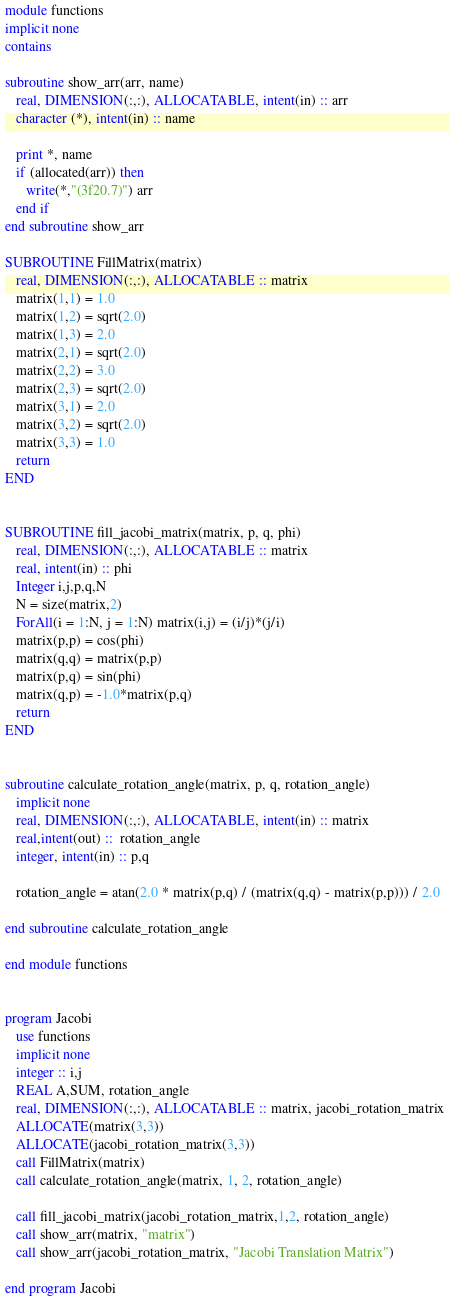<code> <loc_0><loc_0><loc_500><loc_500><_FORTRAN_>module functions
implicit none
contains

subroutine show_arr(arr, name)
   real, DIMENSION(:,:), ALLOCATABLE, intent(in) :: arr
   character (*), intent(in) :: name

   print *, name
   if (allocated(arr)) then
      write(*,"(3f20.7)") arr
   end if
end subroutine show_arr

SUBROUTINE FillMatrix(matrix)
   real, DIMENSION(:,:), ALLOCATABLE :: matrix
   matrix(1,1) = 1.0
   matrix(1,2) = sqrt(2.0)
   matrix(1,3) = 2.0
   matrix(2,1) = sqrt(2.0)
   matrix(2,2) = 3.0
   matrix(2,3) = sqrt(2.0)
   matrix(3,1) = 2.0
   matrix(3,2) = sqrt(2.0)
   matrix(3,3) = 1.0
   return
END


SUBROUTINE fill_jacobi_matrix(matrix, p, q, phi)
   real, DIMENSION(:,:), ALLOCATABLE :: matrix
   real, intent(in) :: phi
   Integer i,j,p,q,N
   N = size(matrix,2)
   ForAll(i = 1:N, j = 1:N) matrix(i,j) = (i/j)*(j/i)
   matrix(p,p) = cos(phi)
   matrix(q,q) = matrix(p,p)
   matrix(p,q) = sin(phi)
   matrix(q,p) = -1.0*matrix(p,q)
   return
END


subroutine calculate_rotation_angle(matrix, p, q, rotation_angle)
   implicit none
   real, DIMENSION(:,:), ALLOCATABLE, intent(in) :: matrix
   real,intent(out) ::  rotation_angle
   integer, intent(in) :: p,q

   rotation_angle = atan(2.0 * matrix(p,q) / (matrix(q,q) - matrix(p,p))) / 2.0

end subroutine calculate_rotation_angle

end module functions


program Jacobi
   use functions
   implicit none
   integer :: i,j
   REAL A,SUM, rotation_angle
   real, DIMENSION(:,:), ALLOCATABLE :: matrix, jacobi_rotation_matrix
   ALLOCATE(matrix(3,3))
   ALLOCATE(jacobi_rotation_matrix(3,3))
   call FillMatrix(matrix)
   call calculate_rotation_angle(matrix, 1, 2, rotation_angle)
   
   call fill_jacobi_matrix(jacobi_rotation_matrix,1,2, rotation_angle)
   call show_arr(matrix, "matrix")
   call show_arr(jacobi_rotation_matrix, "Jacobi Translation Matrix")

end program Jacobi
</code> 